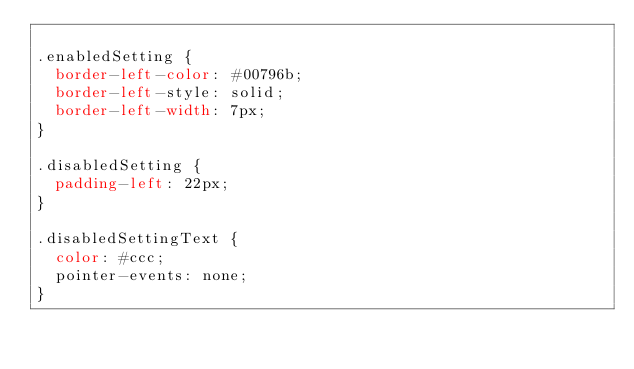<code> <loc_0><loc_0><loc_500><loc_500><_CSS_>
.enabledSetting {
  border-left-color: #00796b;
  border-left-style: solid;
  border-left-width: 7px;
}

.disabledSetting {
  padding-left: 22px;
}

.disabledSettingText {
  color: #ccc;
  pointer-events: none;
}

</code> 